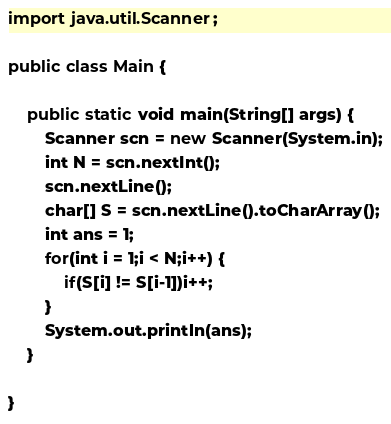Convert code to text. <code><loc_0><loc_0><loc_500><loc_500><_Java_>import java.util.Scanner;

public class Main {

	public static void main(String[] args) {
		Scanner scn = new Scanner(System.in);
		int N = scn.nextInt();
		scn.nextLine();
		char[] S = scn.nextLine().toCharArray();
		int ans = 1;
		for(int i = 1;i < N;i++) {
			if(S[i] != S[i-1])i++;
		}
		System.out.println(ans);
	}

}</code> 